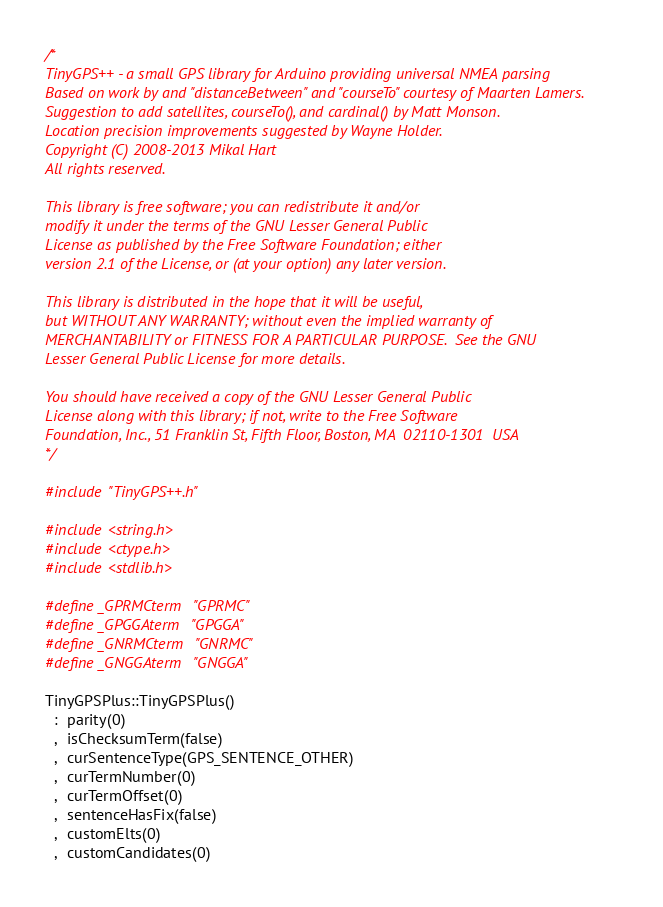Convert code to text. <code><loc_0><loc_0><loc_500><loc_500><_C++_>/*
TinyGPS++ - a small GPS library for Arduino providing universal NMEA parsing
Based on work by and "distanceBetween" and "courseTo" courtesy of Maarten Lamers.
Suggestion to add satellites, courseTo(), and cardinal() by Matt Monson.
Location precision improvements suggested by Wayne Holder.
Copyright (C) 2008-2013 Mikal Hart
All rights reserved.

This library is free software; you can redistribute it and/or
modify it under the terms of the GNU Lesser General Public
License as published by the Free Software Foundation; either
version 2.1 of the License, or (at your option) any later version.

This library is distributed in the hope that it will be useful,
but WITHOUT ANY WARRANTY; without even the implied warranty of
MERCHANTABILITY or FITNESS FOR A PARTICULAR PURPOSE.  See the GNU
Lesser General Public License for more details.

You should have received a copy of the GNU Lesser General Public
License along with this library; if not, write to the Free Software
Foundation, Inc., 51 Franklin St, Fifth Floor, Boston, MA  02110-1301  USA
*/

#include "TinyGPS++.h"

#include <string.h>
#include <ctype.h>
#include <stdlib.h>

#define _GPRMCterm   "GPRMC"
#define _GPGGAterm   "GPGGA"
#define _GNRMCterm   "GNRMC"
#define _GNGGAterm   "GNGGA"

TinyGPSPlus::TinyGPSPlus()
  :  parity(0)
  ,  isChecksumTerm(false)
  ,  curSentenceType(GPS_SENTENCE_OTHER)
  ,  curTermNumber(0)
  ,  curTermOffset(0)
  ,  sentenceHasFix(false)
  ,  customElts(0)
  ,  customCandidates(0)</code> 